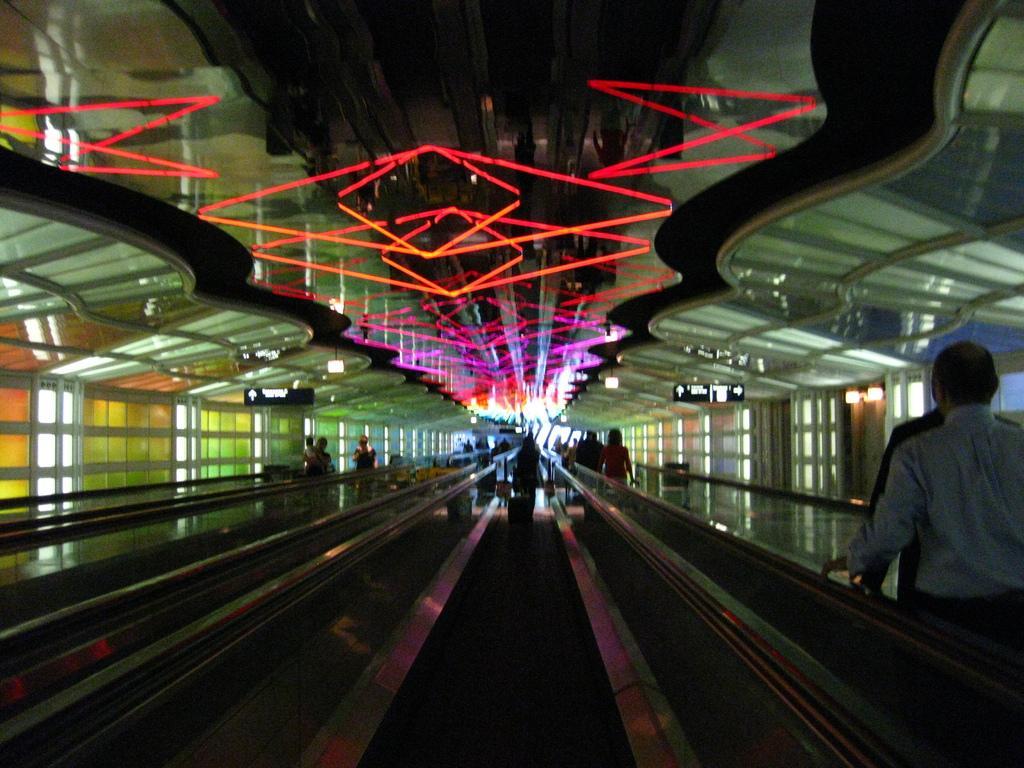How would you summarize this image in a sentence or two? In this picture I can see the escalators. I can see the people. I can see light arrangements on the roof. I can see glass windows. 